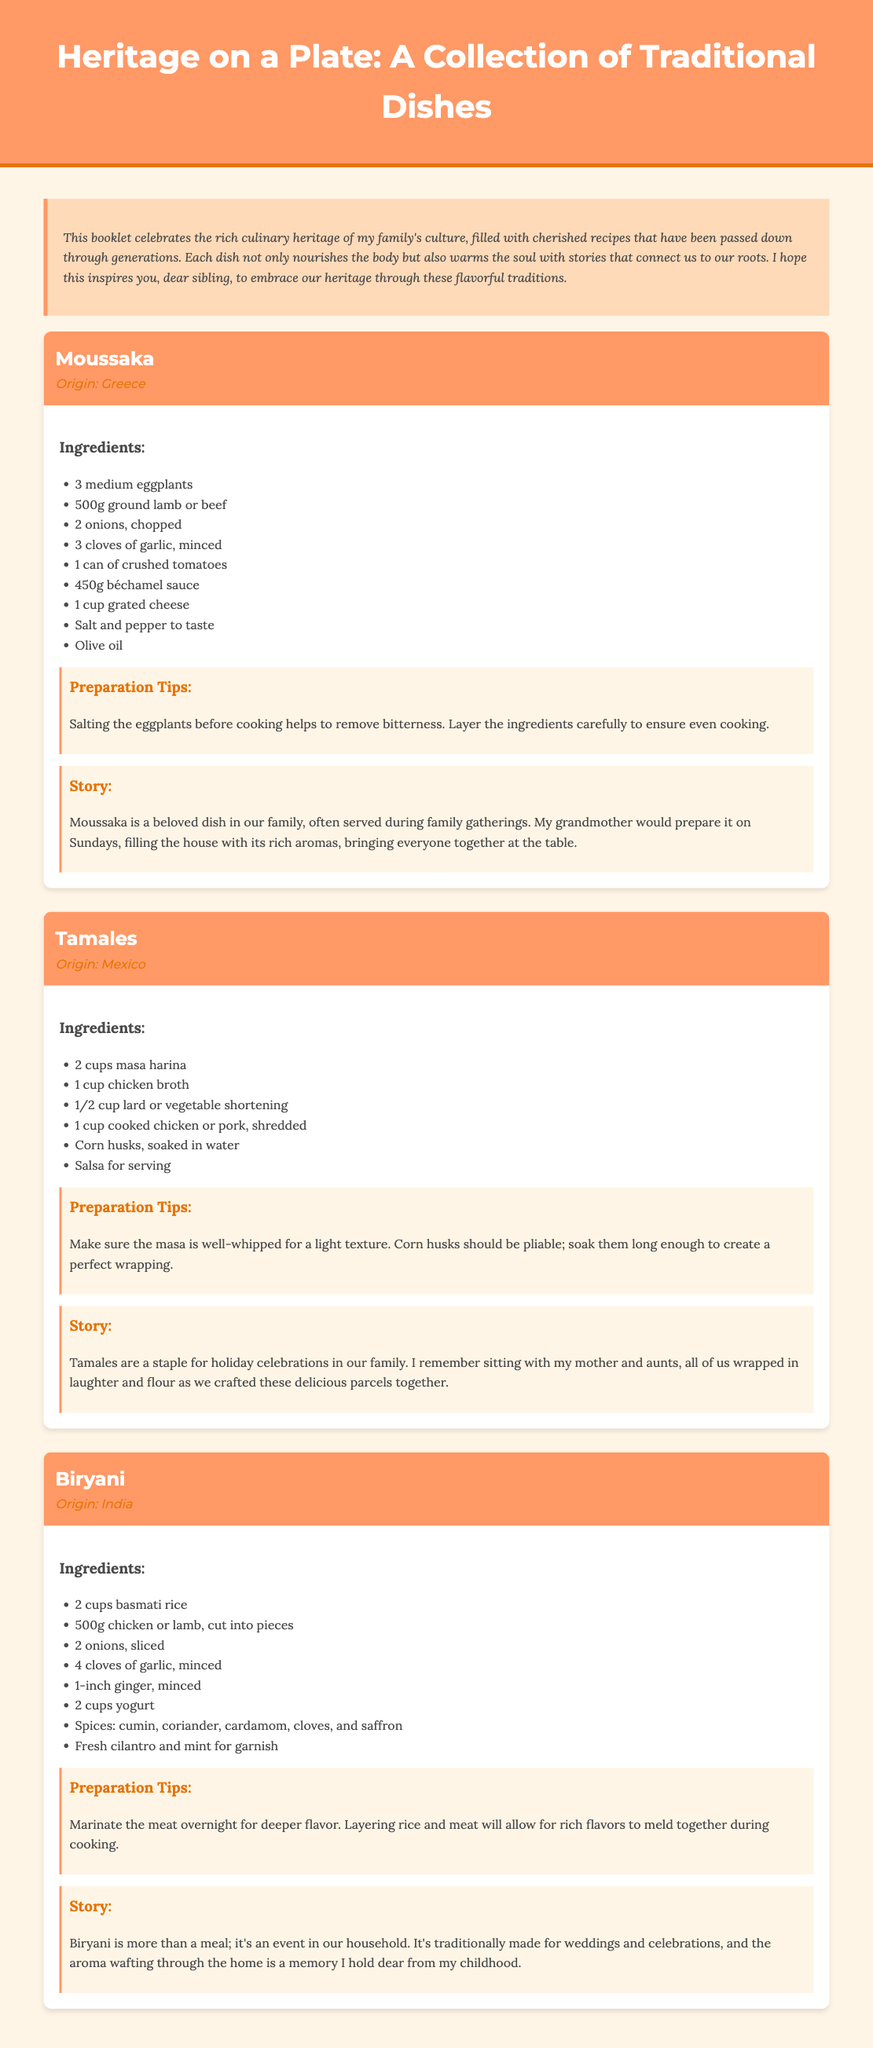What is the title of the booklet? The title is stated at the top of the document in the header section.
Answer: Heritage on a Plate: A Collection of Traditional Dishes How many recipes are included in the booklet? The document contains three distinct recipe sections.
Answer: 3 What is the origin of Moussaka? The origin is indicated under the recipe header of Moussaka.
Answer: Greece What ingredient is used as a base for Tamales? The ingredient is listed under the Ingredients section for the Tamales recipe.
Answer: Masa harina What is a preparation tip for Biryani? The tip can be found in the Preparation Tips section of the Biryani recipe.
Answer: Marinate the meat overnight for deeper flavor Which dish is traditionally made for weddings? The specific dish is mentioned in the Story section of the Biryani recipe.
Answer: Biryani What color is the background of the booklet? The background color is indicated in the body style section of the code.
Answer: #FFF5E6 What type of dish is Moussaka? The type is identified in the context of the recipe's description.
Answer: Casserole 